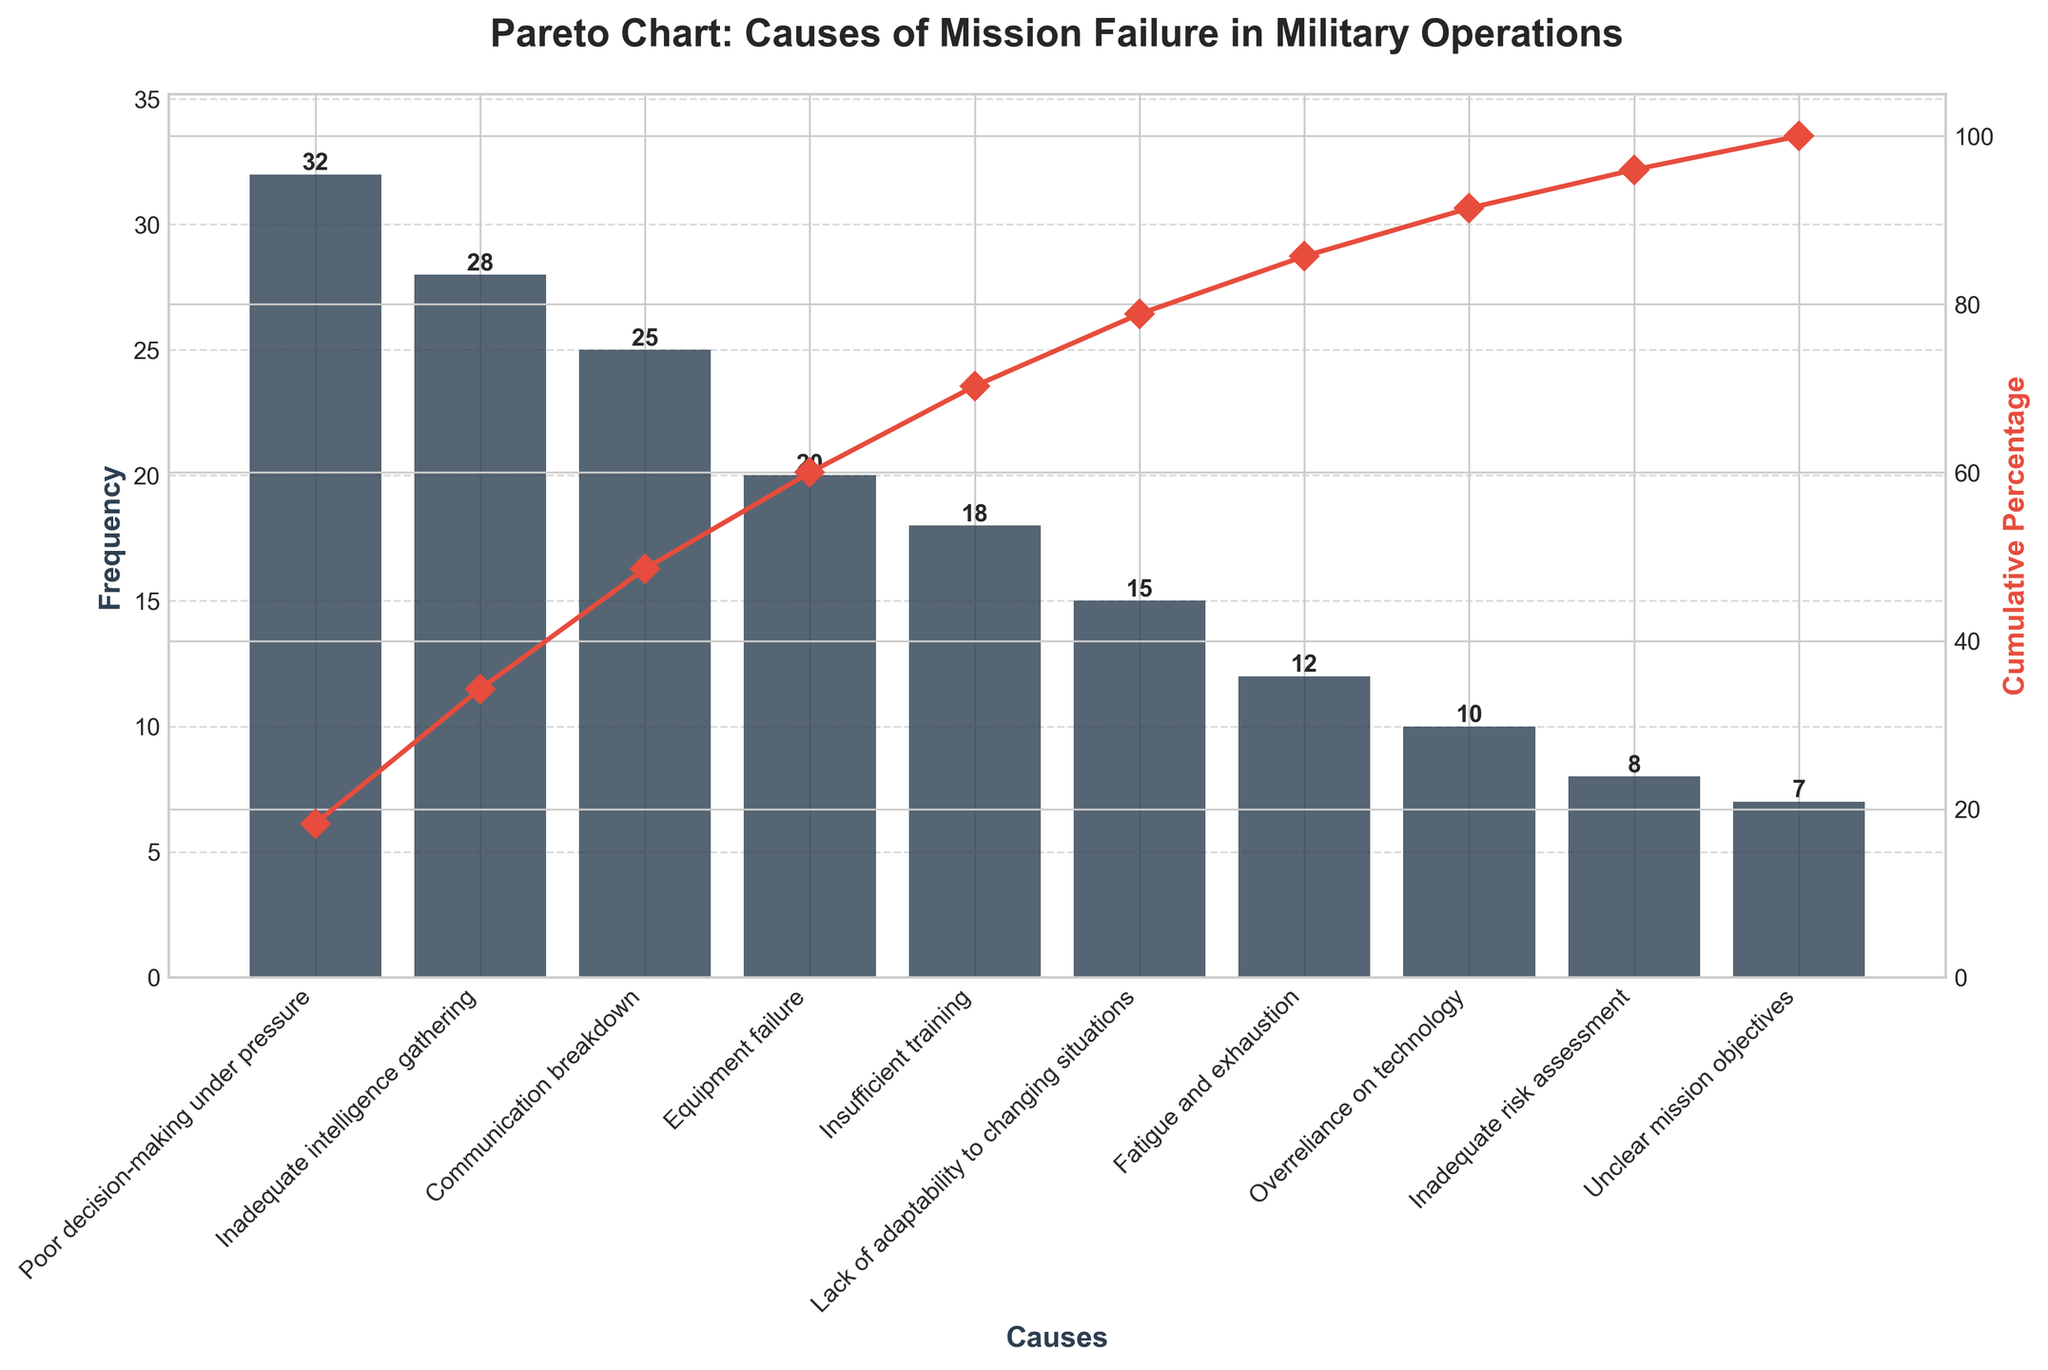What is the title of the figure? The title of the figure is prominently displayed at the top of the plot. This is typically the first piece of information one sees. The plot's title provides context.
Answer: Pareto Chart: Causes of Mission Failure in Military Operations What are the two axes in the figure, and what do they represent? The two axes in a Pareto chart typically represent different types of data. In this figure, the left axis represents the frequency of each cause, and the right axis represents the cumulative percentage.
Answer: Left axis: Frequency, Right axis: Cumulative Percentage Which cause has the highest frequency? To determine the cause with the highest frequency, one must look at the height of the bars. The tallest bar represents the highest frequency.
Answer: Poor decision-making under pressure What is the cumulative percentage for the first three causes combined? Sum the frequencies of 'Poor decision-making under pressure,' 'Inadequate intelligence gathering,' and 'Communication breakdown' and divide by the total frequency, then multiply by 100. This value represents the cumulative percentage shown by the line plot.
Answer: (32 + 28 + 25) / 175 * 100 = 49.14% Which cause has a higher frequency: Equipment failure or Insufficient training? Compare the heights of the bars labeled 'Equipment failure' and 'Insufficient training.' The taller bar indicates a higher frequency.
Answer: Equipment Failure What is the frequency difference between 'Fatigue and exhaustion' and 'Overreliance on technology'? Subtract the frequency of 'Overreliance on technology' from that of 'Fatigue and exhaustion.' This difference shows the disparity in frequency between these two causes.
Answer: 12 - 10 = 2 Which cause has the lowest frequency and what is its value? Identify the shortest bar in the chart. The label of this bar is the cause with the lowest frequency, and the height of the bar indicates its value.
Answer: Unclear mission objectives, 7 How many causes have a frequency greater than or equal to 20? Count the number of bars with heights equal to or exceeding the 20-mark on the frequency axis.
Answer: 4 causes What is the cumulative percentage after considering 'Fatigue and exhaustion'? Calculate the cumulative frequency up to and including 'Fatigue and exhaustion' then divide by the total frequency and multiply by 100. Follow the cumulative line plot to confirm.
Answer: (32 + 28 + 25 + 20 + 18 + 15 + 12) / 175 * 100 = 85.71% 